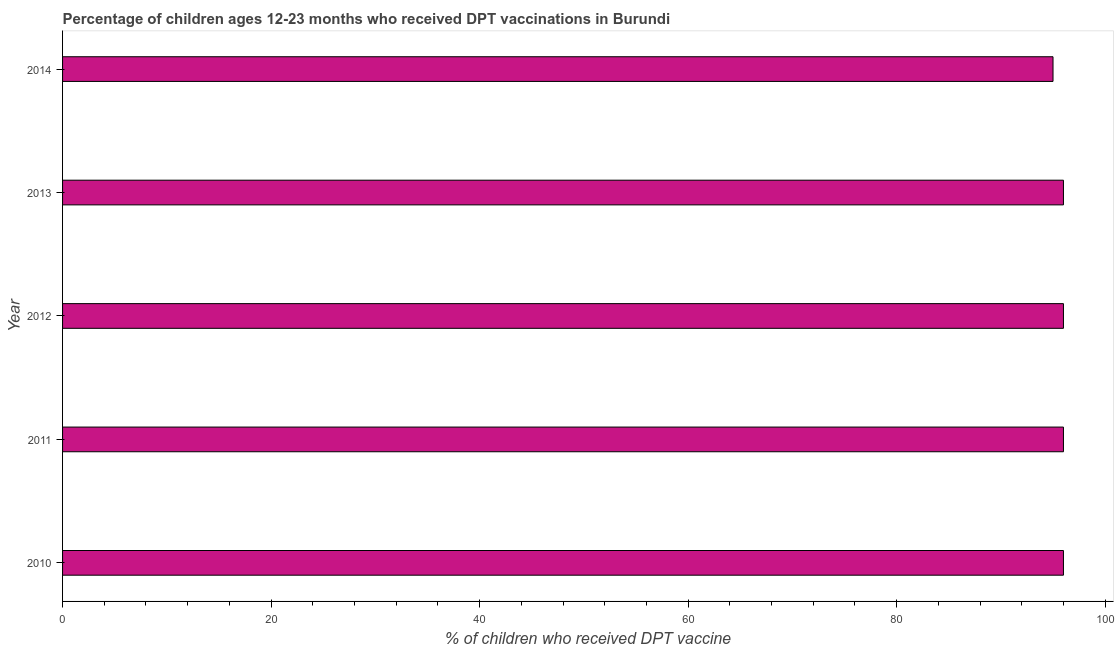Does the graph contain grids?
Ensure brevity in your answer.  No. What is the title of the graph?
Provide a succinct answer. Percentage of children ages 12-23 months who received DPT vaccinations in Burundi. What is the label or title of the X-axis?
Keep it short and to the point. % of children who received DPT vaccine. What is the label or title of the Y-axis?
Your response must be concise. Year. What is the percentage of children who received dpt vaccine in 2011?
Provide a succinct answer. 96. Across all years, what is the maximum percentage of children who received dpt vaccine?
Your response must be concise. 96. Across all years, what is the minimum percentage of children who received dpt vaccine?
Your answer should be compact. 95. In which year was the percentage of children who received dpt vaccine maximum?
Keep it short and to the point. 2010. What is the sum of the percentage of children who received dpt vaccine?
Ensure brevity in your answer.  479. What is the median percentage of children who received dpt vaccine?
Keep it short and to the point. 96. Do a majority of the years between 2014 and 2011 (inclusive) have percentage of children who received dpt vaccine greater than 96 %?
Your answer should be very brief. Yes. Is the percentage of children who received dpt vaccine in 2010 less than that in 2011?
Ensure brevity in your answer.  No. What is the difference between the highest and the second highest percentage of children who received dpt vaccine?
Keep it short and to the point. 0. What is the difference between the highest and the lowest percentage of children who received dpt vaccine?
Provide a short and direct response. 1. In how many years, is the percentage of children who received dpt vaccine greater than the average percentage of children who received dpt vaccine taken over all years?
Your response must be concise. 4. How many bars are there?
Provide a succinct answer. 5. What is the difference between two consecutive major ticks on the X-axis?
Provide a short and direct response. 20. What is the % of children who received DPT vaccine in 2010?
Your answer should be compact. 96. What is the % of children who received DPT vaccine of 2011?
Keep it short and to the point. 96. What is the % of children who received DPT vaccine of 2012?
Keep it short and to the point. 96. What is the % of children who received DPT vaccine in 2013?
Your answer should be very brief. 96. What is the difference between the % of children who received DPT vaccine in 2010 and 2011?
Your response must be concise. 0. What is the difference between the % of children who received DPT vaccine in 2010 and 2014?
Make the answer very short. 1. What is the difference between the % of children who received DPT vaccine in 2011 and 2012?
Keep it short and to the point. 0. What is the difference between the % of children who received DPT vaccine in 2011 and 2013?
Offer a very short reply. 0. What is the difference between the % of children who received DPT vaccine in 2011 and 2014?
Provide a succinct answer. 1. What is the difference between the % of children who received DPT vaccine in 2012 and 2013?
Give a very brief answer. 0. What is the ratio of the % of children who received DPT vaccine in 2010 to that in 2011?
Offer a very short reply. 1. What is the ratio of the % of children who received DPT vaccine in 2010 to that in 2014?
Your answer should be compact. 1.01. What is the ratio of the % of children who received DPT vaccine in 2011 to that in 2012?
Your answer should be compact. 1. What is the ratio of the % of children who received DPT vaccine in 2012 to that in 2013?
Ensure brevity in your answer.  1. What is the ratio of the % of children who received DPT vaccine in 2012 to that in 2014?
Your answer should be very brief. 1.01. 